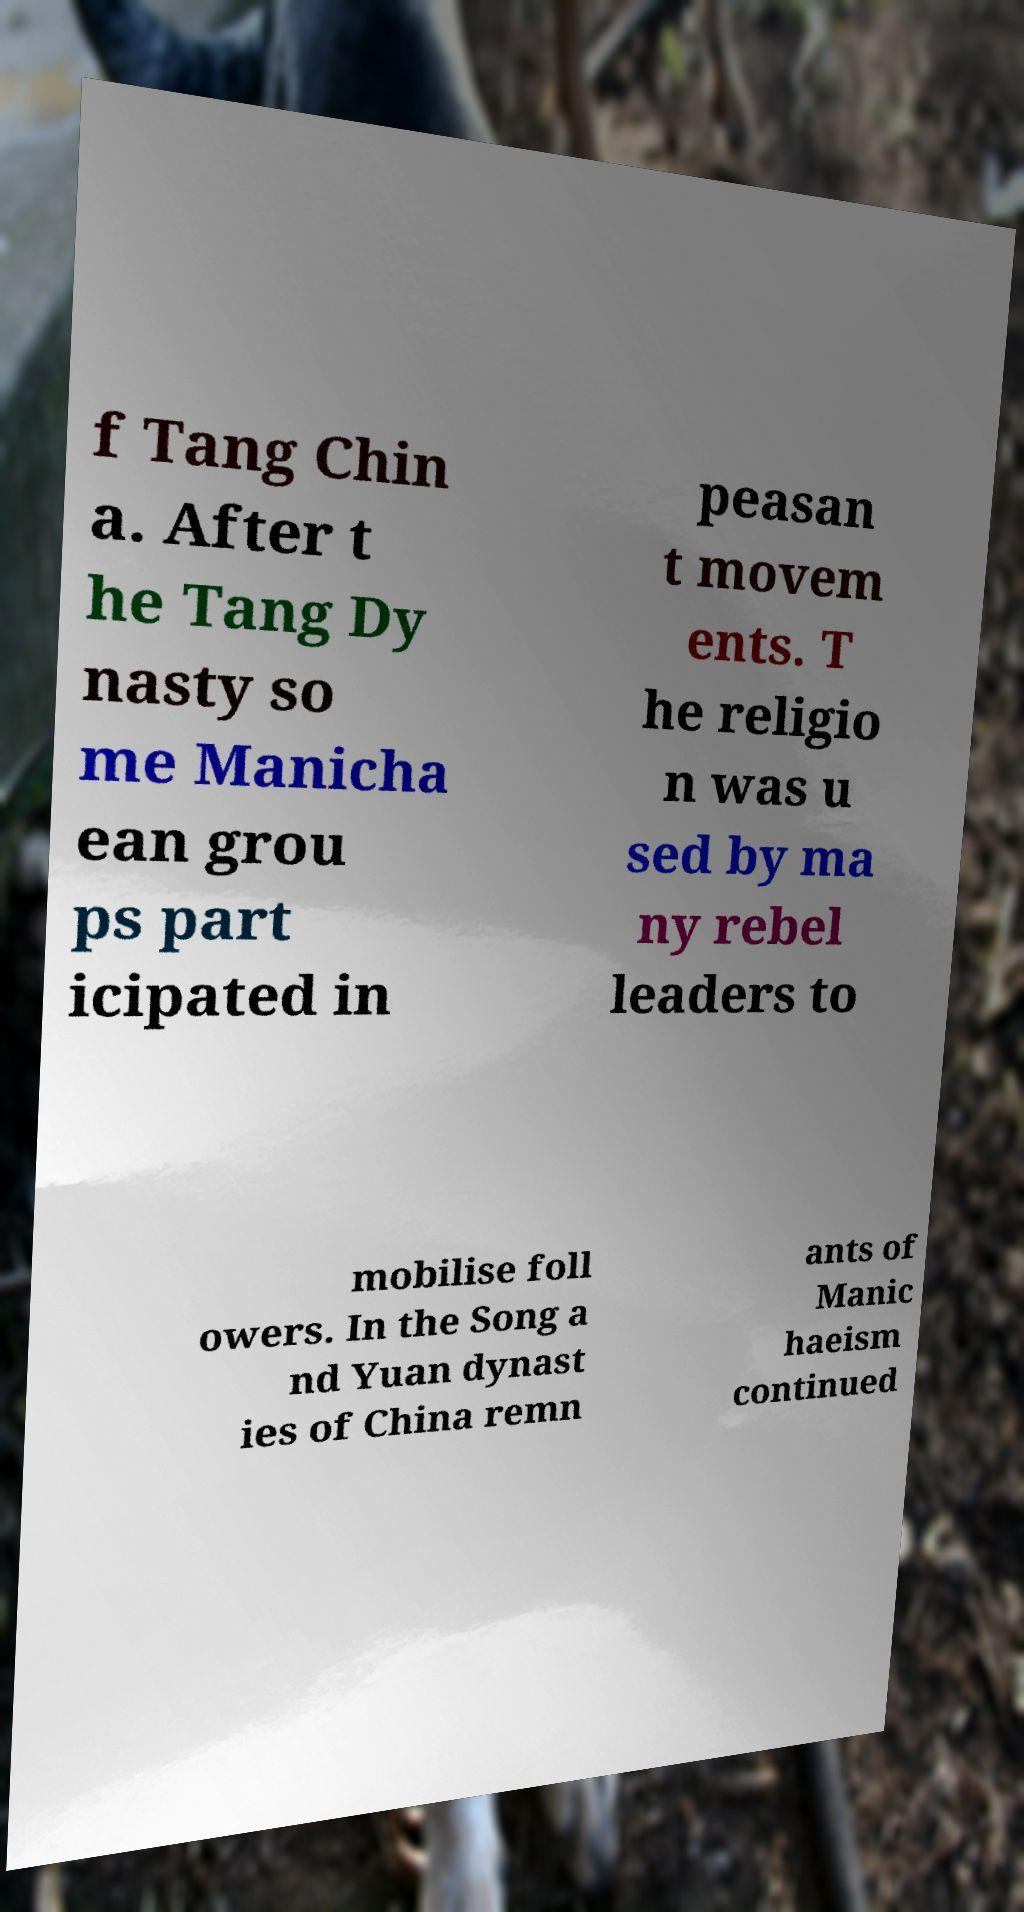Please read and relay the text visible in this image. What does it say? f Tang Chin a. After t he Tang Dy nasty so me Manicha ean grou ps part icipated in peasan t movem ents. T he religio n was u sed by ma ny rebel leaders to mobilise foll owers. In the Song a nd Yuan dynast ies of China remn ants of Manic haeism continued 